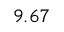Convert formula to latex. <formula><loc_0><loc_0><loc_500><loc_500>9 . 6 7</formula> 